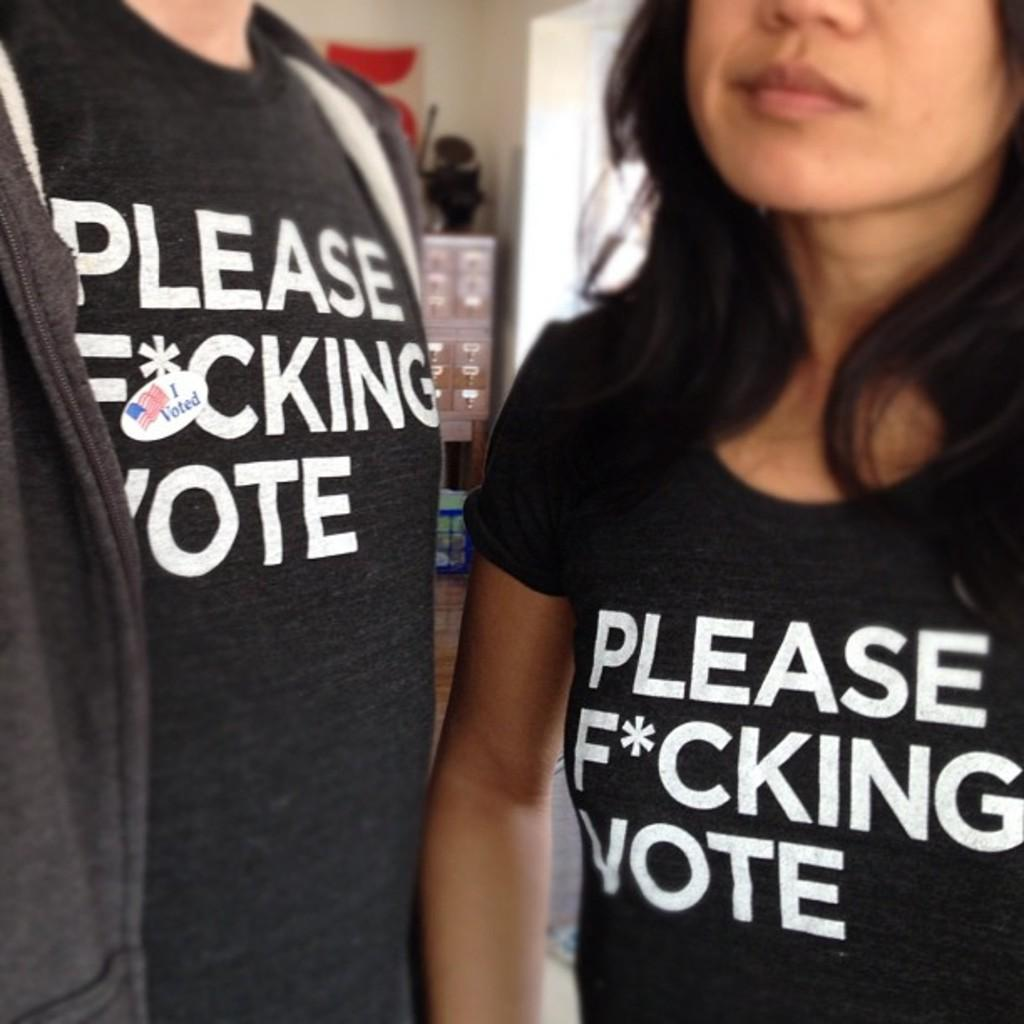<image>
Relay a brief, clear account of the picture shown. Two people standing next two each other in black t-shirts and one has a sticker saying I voted. 